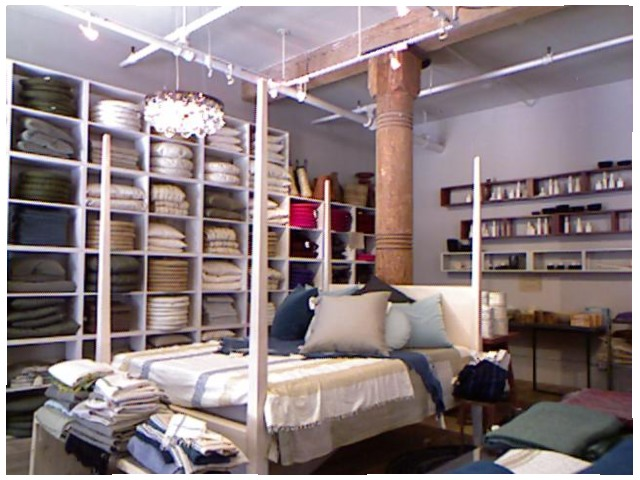<image>
Can you confirm if the pillow is on the bed? No. The pillow is not positioned on the bed. They may be near each other, but the pillow is not supported by or resting on top of the bed. Where is the pipe in relation to the bed? Is it behind the bed? Yes. From this viewpoint, the pipe is positioned behind the bed, with the bed partially or fully occluding the pipe. Is the pole to the left of the pole? No. The pole is not to the left of the pole. From this viewpoint, they have a different horizontal relationship. Is the pillow cushion in the shelf? Yes. The pillow cushion is contained within or inside the shelf, showing a containment relationship. 